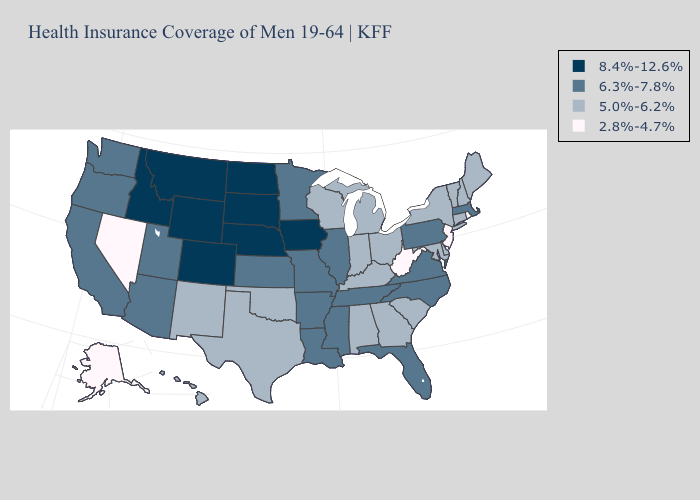What is the lowest value in the MidWest?
Be succinct. 5.0%-6.2%. Which states hav the highest value in the South?
Write a very short answer. Arkansas, Florida, Louisiana, Mississippi, North Carolina, Tennessee, Virginia. Name the states that have a value in the range 2.8%-4.7%?
Be succinct. Alaska, Nevada, New Jersey, Rhode Island, West Virginia. Does West Virginia have the lowest value in the South?
Keep it brief. Yes. Does West Virginia have the lowest value in the South?
Be succinct. Yes. What is the value of Washington?
Be succinct. 6.3%-7.8%. Does New Jersey have the same value as South Dakota?
Write a very short answer. No. Does the map have missing data?
Answer briefly. No. Among the states that border Kansas , does Nebraska have the highest value?
Answer briefly. Yes. Is the legend a continuous bar?
Answer briefly. No. Does the first symbol in the legend represent the smallest category?
Give a very brief answer. No. Does Wyoming have the lowest value in the West?
Be succinct. No. What is the highest value in the USA?
Be succinct. 8.4%-12.6%. Name the states that have a value in the range 2.8%-4.7%?
Quick response, please. Alaska, Nevada, New Jersey, Rhode Island, West Virginia. What is the value of North Carolina?
Write a very short answer. 6.3%-7.8%. 